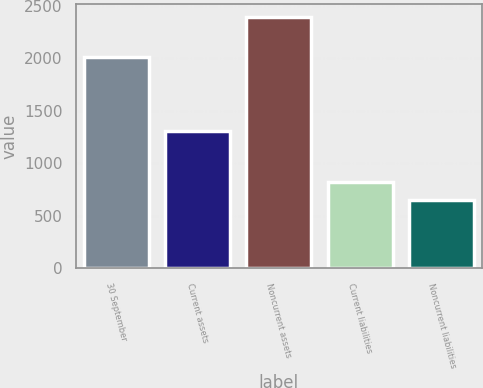Convert chart to OTSL. <chart><loc_0><loc_0><loc_500><loc_500><bar_chart><fcel>30 September<fcel>Current assets<fcel>Noncurrent assets<fcel>Current liabilities<fcel>Noncurrent liabilities<nl><fcel>2013<fcel>1307.9<fcel>2396.1<fcel>823.35<fcel>648.6<nl></chart> 